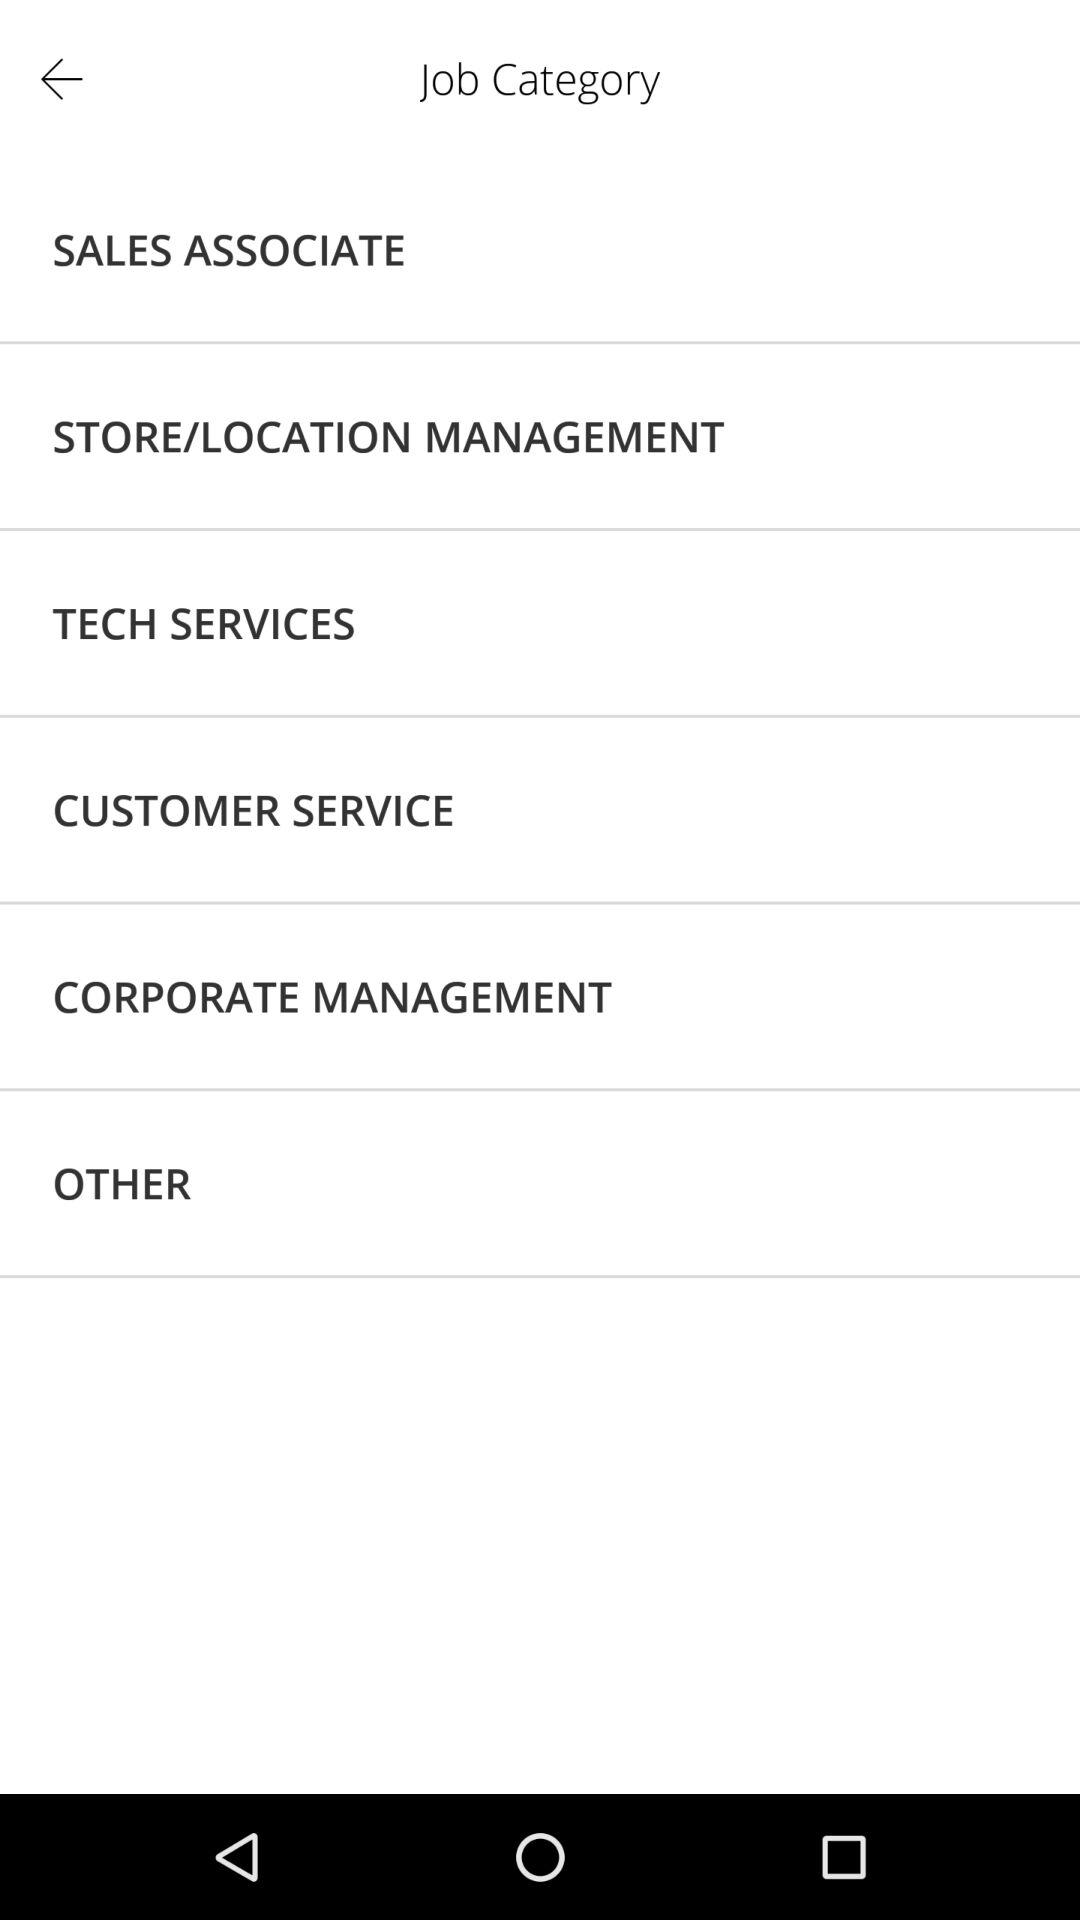What are the various job categories? The various job categories are "SALES ASSOCIATE", "STORE/LOCATION MANAGEMENT", "TECH SERVICES", "CUSTOMER SERVICE" and "CORPORATE MANAGEMENT". 